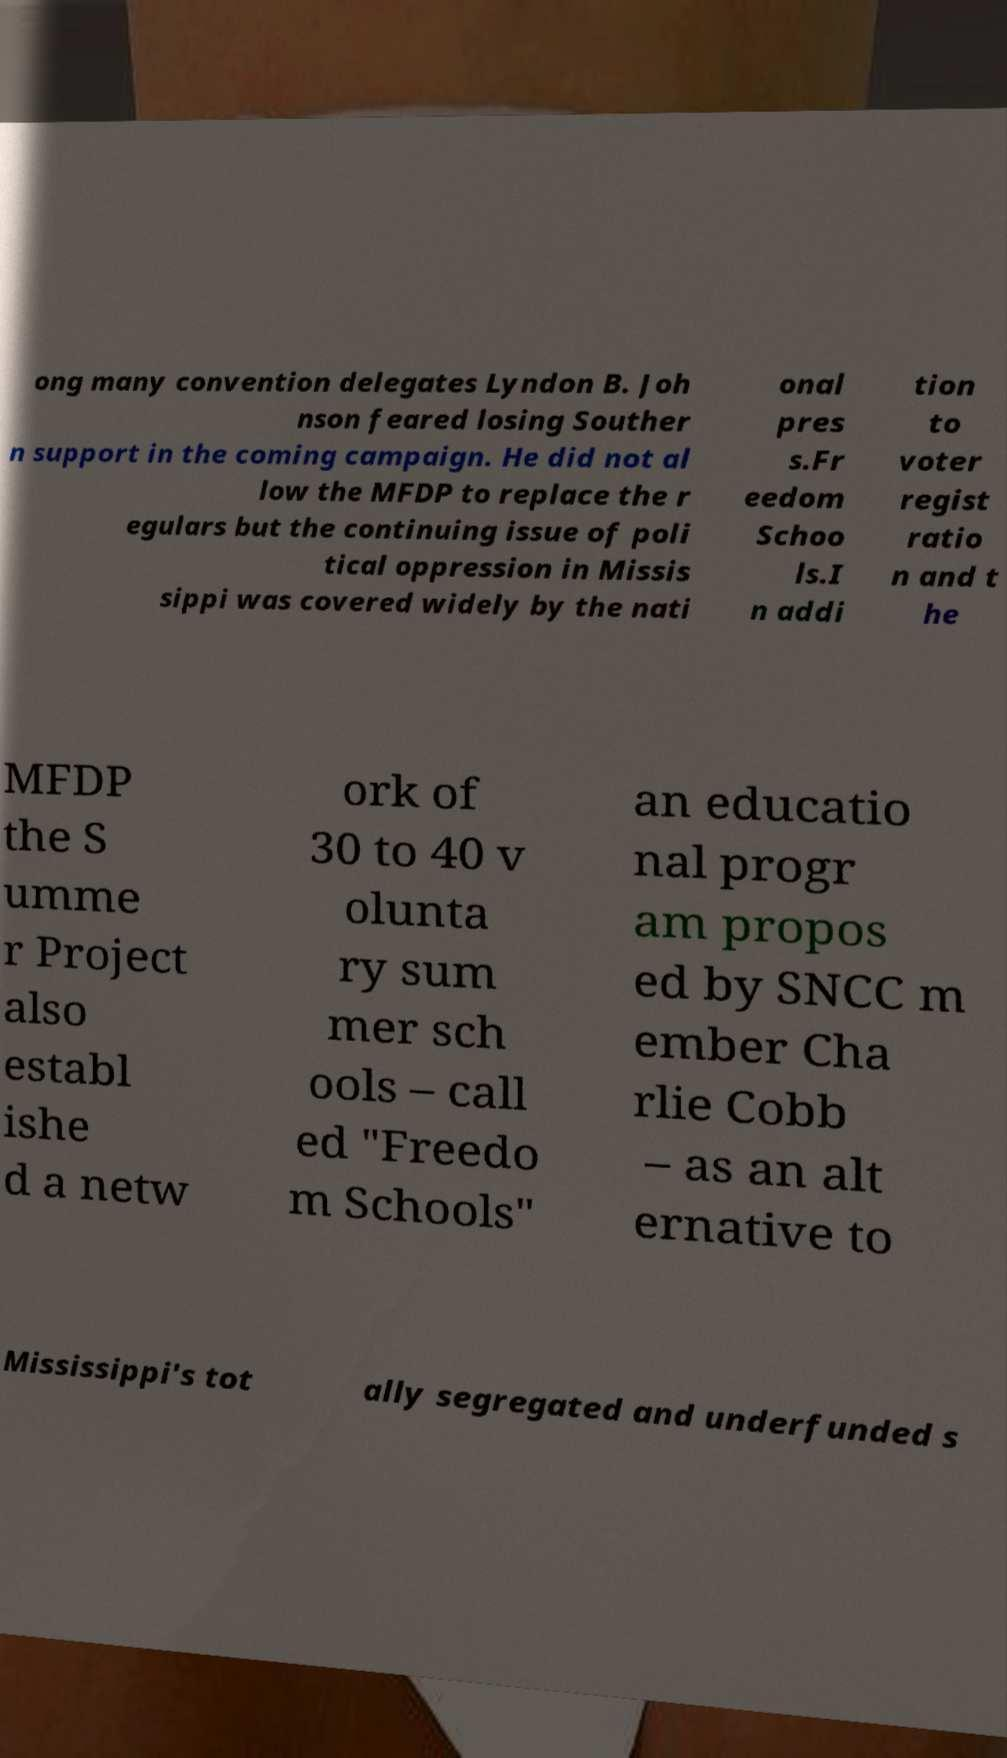What messages or text are displayed in this image? I need them in a readable, typed format. ong many convention delegates Lyndon B. Joh nson feared losing Souther n support in the coming campaign. He did not al low the MFDP to replace the r egulars but the continuing issue of poli tical oppression in Missis sippi was covered widely by the nati onal pres s.Fr eedom Schoo ls.I n addi tion to voter regist ratio n and t he MFDP the S umme r Project also establ ishe d a netw ork of 30 to 40 v olunta ry sum mer sch ools – call ed "Freedo m Schools" an educatio nal progr am propos ed by SNCC m ember Cha rlie Cobb – as an alt ernative to Mississippi's tot ally segregated and underfunded s 